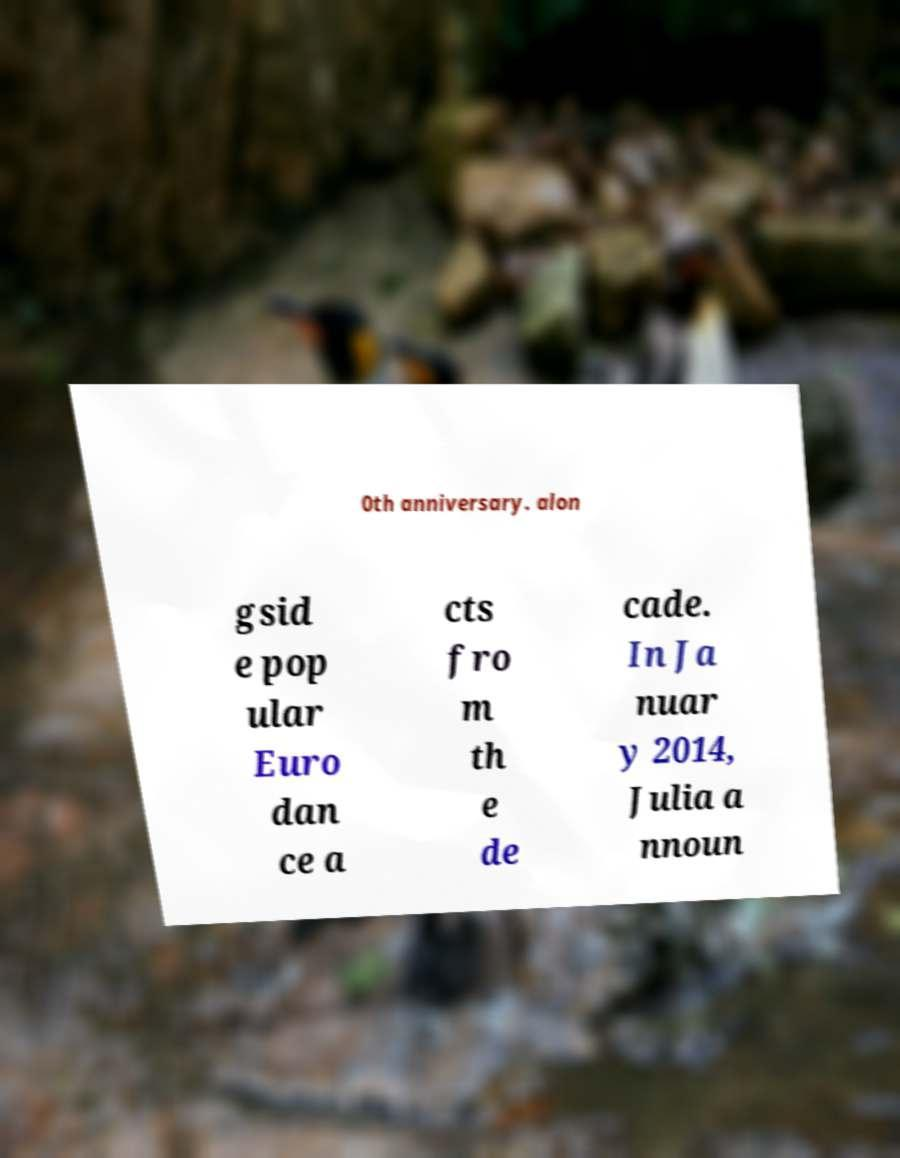Can you accurately transcribe the text from the provided image for me? 0th anniversary. alon gsid e pop ular Euro dan ce a cts fro m th e de cade. In Ja nuar y 2014, Julia a nnoun 